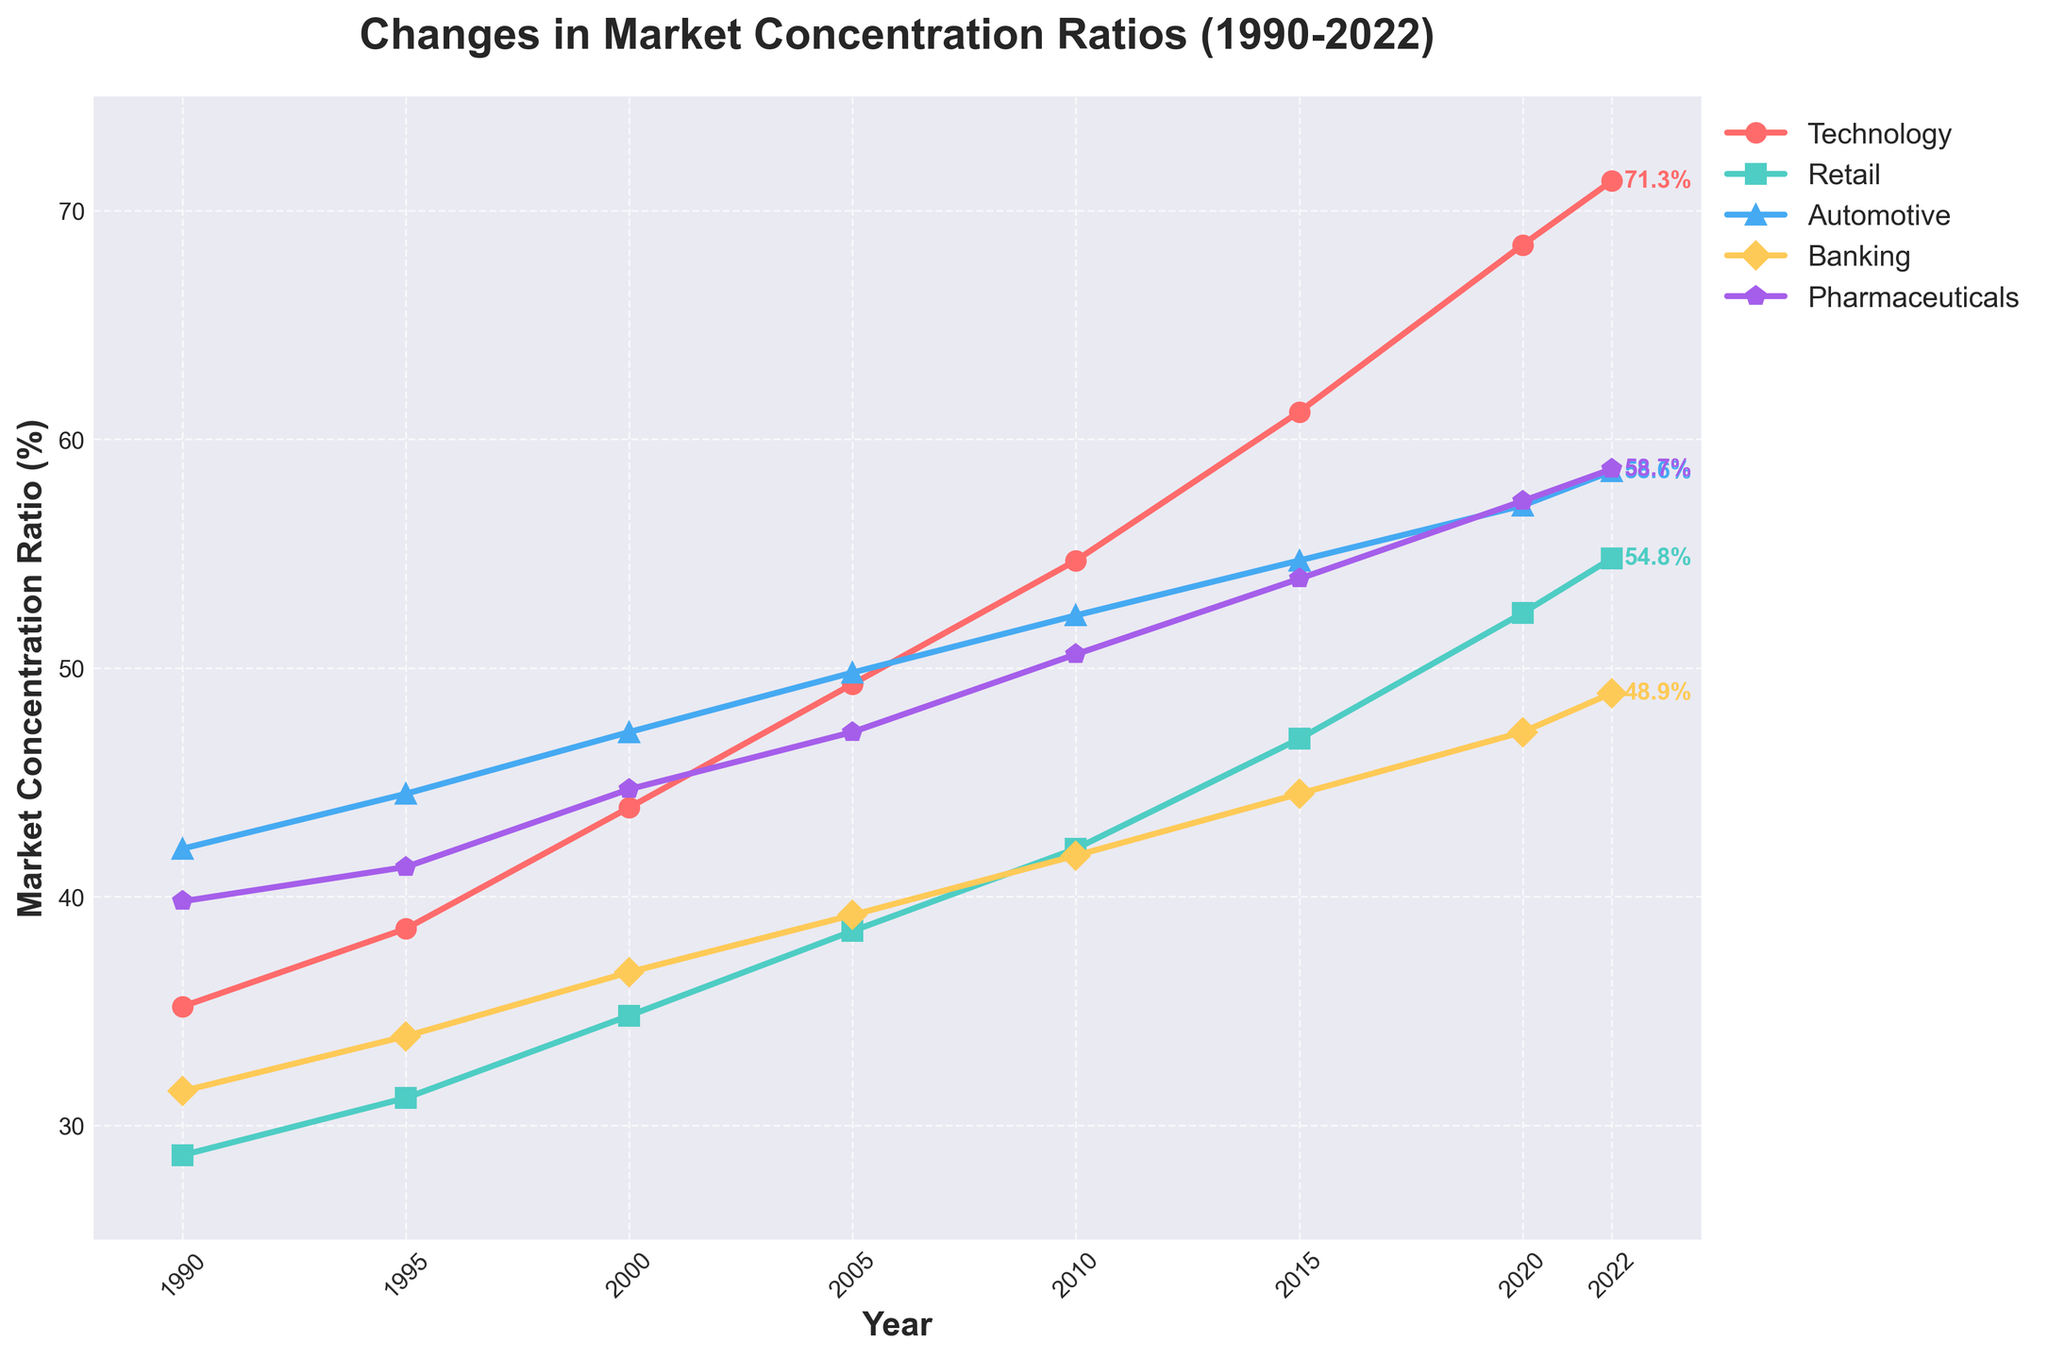What industry shows the largest increase in market concentration ratio from 1990 to 2022? Explanation: To find the industry with the largest increase, calculate the difference between 2022 and 1990 for each industry and compare the results. Technology: 71.3 - 35.2 = 36.1, Retail: 54.8 - 28.7 = 26.1, Automotive: 58.6 - 42.1 = 16.5, Banking: 48.9 - 31.5 = 17.4, Pharmaceuticals: 58.7 - 39.8 = 18.9. Technology has the largest increase of 36.1.
Answer: Technology Which industry had the highest market concentration ratio in 2022? Explanation: Examine the market concentration ratios for each industry in 2022: Technology: 71.3, Retail: 54.8, Automotive: 58.6, Banking: 48.9, Pharmaceuticals: 58.7. Technology has the highest ratio of 71.3.
Answer: Technology What is the average market concentration ratio for the top 5 companies in Retail from 1990 to 2022? Explanation: Sum the market concentration ratios for Retail across the years and divide by the number of data points: (28.7 + 31.2 + 34.8 + 38.5 + 42.1 + 46.9 + 52.4 + 54.8) / 8 = 41.175.
Answer: 41.2 Which industry shows the smallest overall change in market concentration ratio from 1990 to 2022? Explanation: Calculate the difference between 2022 and 1990 for each industry and compare the results. Technology: 71.3 - 35.2 = 36.1, Retail: 54.8 - 28.7 = 26.1, Automotive: 58.6 - 42.1 = 16.5, Banking: 48.9 - 31.5 = 17.4, Pharmaceuticals: 58.7 - 39.8 = 18.9. Automotive has the smallest change of 16.5.
Answer: Automotive By how much did the market concentration ratio for Pharmaceuticals increase from 2000 to 2022? Explanation: Subtract the 2000 value from the 2022 value for Pharmaceuticals: 58.7 - 44.7 = 14.0.
Answer: 14.0 Between which consecutive periods did the Banking industry see the largest increase in market concentration ratio? Explanation: Calculate the difference between consecutive years for Banking: 1995-1990: 33.9 - 31.5 = 2.4, 2000-1995: 36.7 - 33.9 = 2.8, 2005-2000: 39.2 - 36.7 = 2.5, 2010-2005: 41.8 - 39.2 = 2.6, 2015-2010: 44.5 - 41.8 = 2.7, 2020-2015: 47.2 - 44.5 = 2.7, 2022-2020: 48.9 - 47.2 = 1.7. The largest increase is between 2015 and 2020 at 2.7.
Answer: 2015 and 2020 Comparing Technology and Retail, which industry had higher market concentration ratios more consistently over the years 1990 to 2022? Explanation: By visually comparing the plots for Technology and Retail from 1990 to 2022, Technology consistently shows higher market concentration ratios in every recorded year.
Answer: Technology What is the trend in market concentration ratios for the Automotive industry from 1990 to 2022? Explanation: Observing the plot for Automotive, the market concentration ratio shows a general increasing trend from 42.1 in 1990 to 58.6 in 2022.
Answer: Increasing What is the average market concentration ratio for Banking over the last three data points (2015, 2020, 2022)? Explanation: Sum the market concentration ratios for Banking for the years 2015, 2020, and 2022, then divide by 3: (44.5 + 47.2 + 48.9) / 3 = 46.87.
Answer: 46.9 Which industries had a market concentration ratio above 50% in 2022? Explanation: Examine the market concentration ratios in 2022 for each industry: Technology: 71.3, Retail: 54.8, Automotive: 58.6, Banking: 48.9, Pharmaceuticals: 58.7. All except Banking (48.9) are above 50%.
Answer: Technology, Retail, Automotive, Pharmaceuticals 